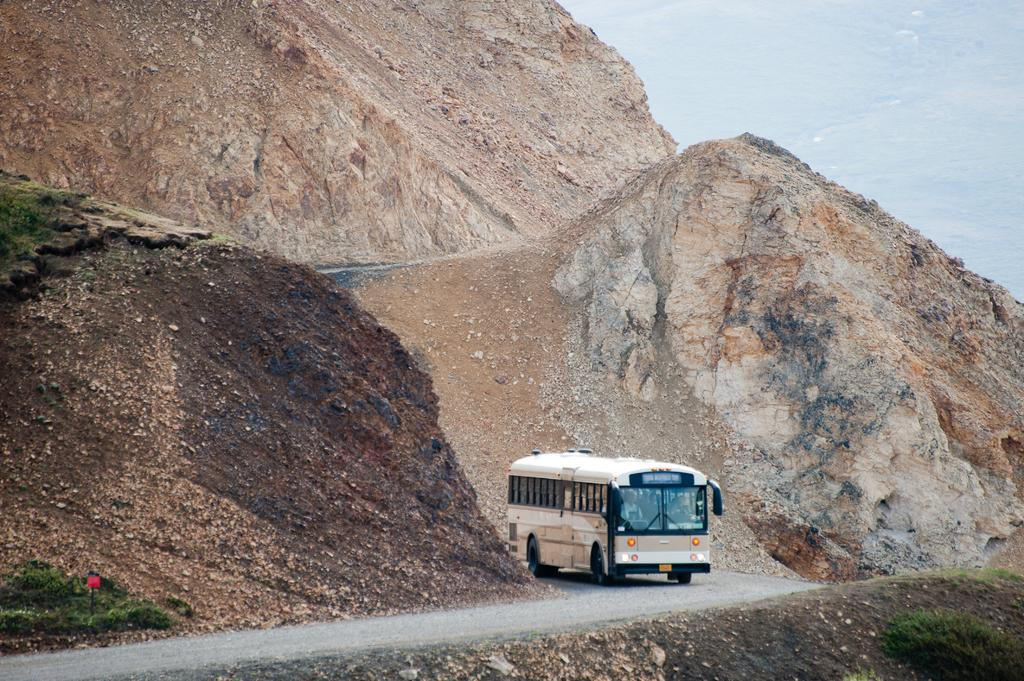What type of vehicle is on the road in the image? There is a bus on the road in the image. What natural feature can be seen in the background of the image? Mountains are visible in the image. Where are plants located at the bottom of the image? There are plants at the bottom left and bottom right sides of the image. How many babies are sitting at the table in the image? There is no table or babies present in the image. What subject is being taught in the class depicted in the image? There is no class or subject being taught in the image. 